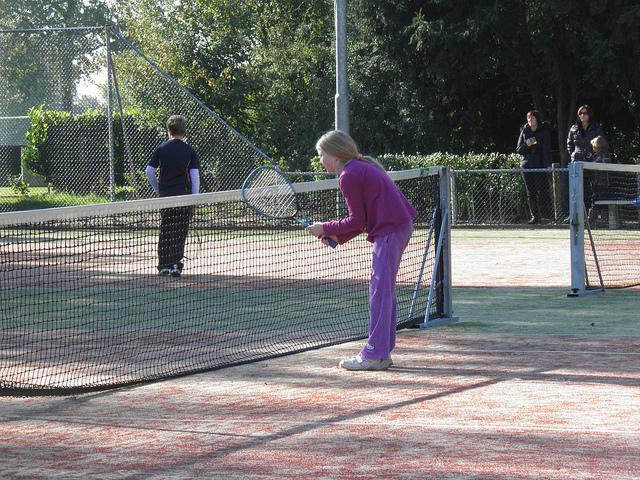How many people are in this scene?
Give a very brief answer. 4. How many people are there?
Give a very brief answer. 3. How many tennis rackets are visible?
Give a very brief answer. 1. How many ski poles is this person holding?
Give a very brief answer. 0. 